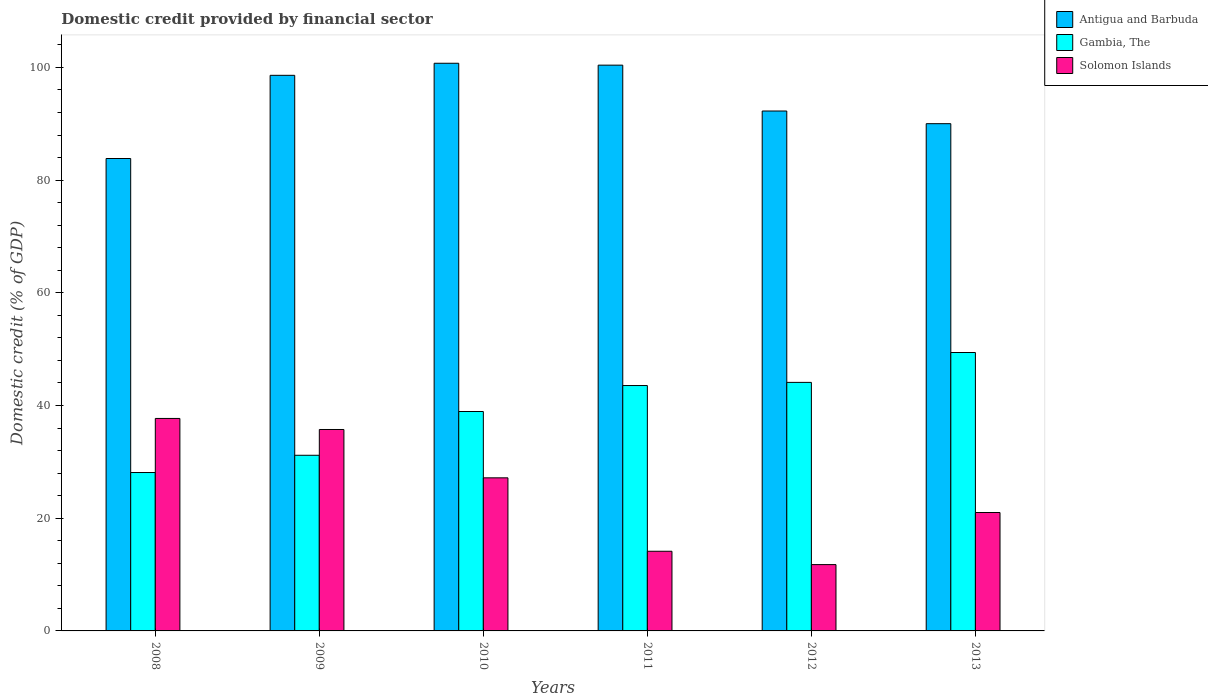How many different coloured bars are there?
Provide a succinct answer. 3. Are the number of bars per tick equal to the number of legend labels?
Keep it short and to the point. Yes. Are the number of bars on each tick of the X-axis equal?
Your answer should be compact. Yes. How many bars are there on the 6th tick from the left?
Make the answer very short. 3. How many bars are there on the 5th tick from the right?
Your response must be concise. 3. In how many cases, is the number of bars for a given year not equal to the number of legend labels?
Make the answer very short. 0. What is the domestic credit in Solomon Islands in 2010?
Your answer should be compact. 27.17. Across all years, what is the maximum domestic credit in Antigua and Barbuda?
Give a very brief answer. 100.74. Across all years, what is the minimum domestic credit in Gambia, The?
Make the answer very short. 28.11. In which year was the domestic credit in Gambia, The minimum?
Give a very brief answer. 2008. What is the total domestic credit in Antigua and Barbuda in the graph?
Your answer should be compact. 565.87. What is the difference between the domestic credit in Solomon Islands in 2010 and that in 2011?
Offer a very short reply. 13.03. What is the difference between the domestic credit in Solomon Islands in 2008 and the domestic credit in Antigua and Barbuda in 2013?
Offer a very short reply. -52.31. What is the average domestic credit in Solomon Islands per year?
Ensure brevity in your answer.  24.59. In the year 2010, what is the difference between the domestic credit in Gambia, The and domestic credit in Solomon Islands?
Make the answer very short. 11.77. In how many years, is the domestic credit in Gambia, The greater than 36 %?
Give a very brief answer. 4. What is the ratio of the domestic credit in Gambia, The in 2008 to that in 2009?
Give a very brief answer. 0.9. Is the difference between the domestic credit in Gambia, The in 2009 and 2013 greater than the difference between the domestic credit in Solomon Islands in 2009 and 2013?
Give a very brief answer. No. What is the difference between the highest and the second highest domestic credit in Gambia, The?
Keep it short and to the point. 5.3. What is the difference between the highest and the lowest domestic credit in Gambia, The?
Offer a terse response. 21.3. In how many years, is the domestic credit in Gambia, The greater than the average domestic credit in Gambia, The taken over all years?
Your answer should be very brief. 3. What does the 3rd bar from the left in 2010 represents?
Provide a short and direct response. Solomon Islands. What does the 1st bar from the right in 2012 represents?
Your answer should be very brief. Solomon Islands. Is it the case that in every year, the sum of the domestic credit in Solomon Islands and domestic credit in Antigua and Barbuda is greater than the domestic credit in Gambia, The?
Provide a succinct answer. Yes. Are all the bars in the graph horizontal?
Offer a very short reply. No. What is the difference between two consecutive major ticks on the Y-axis?
Provide a succinct answer. 20. Are the values on the major ticks of Y-axis written in scientific E-notation?
Provide a short and direct response. No. Does the graph contain grids?
Provide a short and direct response. No. Where does the legend appear in the graph?
Offer a terse response. Top right. What is the title of the graph?
Your answer should be very brief. Domestic credit provided by financial sector. Does "Rwanda" appear as one of the legend labels in the graph?
Give a very brief answer. No. What is the label or title of the X-axis?
Ensure brevity in your answer.  Years. What is the label or title of the Y-axis?
Keep it short and to the point. Domestic credit (% of GDP). What is the Domestic credit (% of GDP) of Antigua and Barbuda in 2008?
Ensure brevity in your answer.  83.84. What is the Domestic credit (% of GDP) of Gambia, The in 2008?
Your answer should be very brief. 28.11. What is the Domestic credit (% of GDP) of Solomon Islands in 2008?
Your response must be concise. 37.71. What is the Domestic credit (% of GDP) of Antigua and Barbuda in 2009?
Ensure brevity in your answer.  98.6. What is the Domestic credit (% of GDP) in Gambia, The in 2009?
Offer a terse response. 31.17. What is the Domestic credit (% of GDP) of Solomon Islands in 2009?
Provide a short and direct response. 35.75. What is the Domestic credit (% of GDP) in Antigua and Barbuda in 2010?
Give a very brief answer. 100.74. What is the Domestic credit (% of GDP) of Gambia, The in 2010?
Provide a short and direct response. 38.94. What is the Domestic credit (% of GDP) in Solomon Islands in 2010?
Provide a short and direct response. 27.17. What is the Domestic credit (% of GDP) in Antigua and Barbuda in 2011?
Provide a short and direct response. 100.4. What is the Domestic credit (% of GDP) of Gambia, The in 2011?
Your answer should be compact. 43.55. What is the Domestic credit (% of GDP) in Solomon Islands in 2011?
Provide a short and direct response. 14.14. What is the Domestic credit (% of GDP) of Antigua and Barbuda in 2012?
Your answer should be very brief. 92.27. What is the Domestic credit (% of GDP) of Gambia, The in 2012?
Give a very brief answer. 44.11. What is the Domestic credit (% of GDP) in Solomon Islands in 2012?
Ensure brevity in your answer.  11.77. What is the Domestic credit (% of GDP) of Antigua and Barbuda in 2013?
Keep it short and to the point. 90.02. What is the Domestic credit (% of GDP) in Gambia, The in 2013?
Ensure brevity in your answer.  49.41. What is the Domestic credit (% of GDP) of Solomon Islands in 2013?
Your response must be concise. 21.01. Across all years, what is the maximum Domestic credit (% of GDP) of Antigua and Barbuda?
Offer a terse response. 100.74. Across all years, what is the maximum Domestic credit (% of GDP) in Gambia, The?
Give a very brief answer. 49.41. Across all years, what is the maximum Domestic credit (% of GDP) in Solomon Islands?
Your answer should be very brief. 37.71. Across all years, what is the minimum Domestic credit (% of GDP) in Antigua and Barbuda?
Your response must be concise. 83.84. Across all years, what is the minimum Domestic credit (% of GDP) in Gambia, The?
Provide a short and direct response. 28.11. Across all years, what is the minimum Domestic credit (% of GDP) in Solomon Islands?
Offer a terse response. 11.77. What is the total Domestic credit (% of GDP) in Antigua and Barbuda in the graph?
Your answer should be compact. 565.87. What is the total Domestic credit (% of GDP) in Gambia, The in the graph?
Provide a short and direct response. 235.28. What is the total Domestic credit (% of GDP) of Solomon Islands in the graph?
Keep it short and to the point. 147.55. What is the difference between the Domestic credit (% of GDP) of Antigua and Barbuda in 2008 and that in 2009?
Give a very brief answer. -14.76. What is the difference between the Domestic credit (% of GDP) in Gambia, The in 2008 and that in 2009?
Provide a succinct answer. -3.06. What is the difference between the Domestic credit (% of GDP) of Solomon Islands in 2008 and that in 2009?
Your answer should be very brief. 1.96. What is the difference between the Domestic credit (% of GDP) in Antigua and Barbuda in 2008 and that in 2010?
Ensure brevity in your answer.  -16.9. What is the difference between the Domestic credit (% of GDP) of Gambia, The in 2008 and that in 2010?
Provide a short and direct response. -10.83. What is the difference between the Domestic credit (% of GDP) in Solomon Islands in 2008 and that in 2010?
Your answer should be compact. 10.54. What is the difference between the Domestic credit (% of GDP) in Antigua and Barbuda in 2008 and that in 2011?
Give a very brief answer. -16.57. What is the difference between the Domestic credit (% of GDP) in Gambia, The in 2008 and that in 2011?
Ensure brevity in your answer.  -15.44. What is the difference between the Domestic credit (% of GDP) in Solomon Islands in 2008 and that in 2011?
Your answer should be very brief. 23.57. What is the difference between the Domestic credit (% of GDP) in Antigua and Barbuda in 2008 and that in 2012?
Your answer should be compact. -8.43. What is the difference between the Domestic credit (% of GDP) in Gambia, The in 2008 and that in 2012?
Keep it short and to the point. -16. What is the difference between the Domestic credit (% of GDP) of Solomon Islands in 2008 and that in 2012?
Provide a succinct answer. 25.94. What is the difference between the Domestic credit (% of GDP) in Antigua and Barbuda in 2008 and that in 2013?
Your answer should be compact. -6.18. What is the difference between the Domestic credit (% of GDP) in Gambia, The in 2008 and that in 2013?
Your answer should be very brief. -21.3. What is the difference between the Domestic credit (% of GDP) in Solomon Islands in 2008 and that in 2013?
Provide a succinct answer. 16.69. What is the difference between the Domestic credit (% of GDP) in Antigua and Barbuda in 2009 and that in 2010?
Offer a very short reply. -2.14. What is the difference between the Domestic credit (% of GDP) in Gambia, The in 2009 and that in 2010?
Offer a terse response. -7.77. What is the difference between the Domestic credit (% of GDP) in Solomon Islands in 2009 and that in 2010?
Ensure brevity in your answer.  8.58. What is the difference between the Domestic credit (% of GDP) of Antigua and Barbuda in 2009 and that in 2011?
Provide a short and direct response. -1.8. What is the difference between the Domestic credit (% of GDP) in Gambia, The in 2009 and that in 2011?
Make the answer very short. -12.37. What is the difference between the Domestic credit (% of GDP) of Solomon Islands in 2009 and that in 2011?
Make the answer very short. 21.61. What is the difference between the Domestic credit (% of GDP) in Antigua and Barbuda in 2009 and that in 2012?
Offer a very short reply. 6.33. What is the difference between the Domestic credit (% of GDP) in Gambia, The in 2009 and that in 2012?
Your answer should be compact. -12.94. What is the difference between the Domestic credit (% of GDP) in Solomon Islands in 2009 and that in 2012?
Provide a short and direct response. 23.98. What is the difference between the Domestic credit (% of GDP) of Antigua and Barbuda in 2009 and that in 2013?
Provide a short and direct response. 8.58. What is the difference between the Domestic credit (% of GDP) of Gambia, The in 2009 and that in 2013?
Give a very brief answer. -18.24. What is the difference between the Domestic credit (% of GDP) in Solomon Islands in 2009 and that in 2013?
Your answer should be compact. 14.73. What is the difference between the Domestic credit (% of GDP) of Antigua and Barbuda in 2010 and that in 2011?
Offer a terse response. 0.34. What is the difference between the Domestic credit (% of GDP) of Gambia, The in 2010 and that in 2011?
Give a very brief answer. -4.61. What is the difference between the Domestic credit (% of GDP) of Solomon Islands in 2010 and that in 2011?
Ensure brevity in your answer.  13.03. What is the difference between the Domestic credit (% of GDP) of Antigua and Barbuda in 2010 and that in 2012?
Give a very brief answer. 8.47. What is the difference between the Domestic credit (% of GDP) in Gambia, The in 2010 and that in 2012?
Offer a terse response. -5.17. What is the difference between the Domestic credit (% of GDP) of Solomon Islands in 2010 and that in 2012?
Your response must be concise. 15.4. What is the difference between the Domestic credit (% of GDP) of Antigua and Barbuda in 2010 and that in 2013?
Ensure brevity in your answer.  10.72. What is the difference between the Domestic credit (% of GDP) of Gambia, The in 2010 and that in 2013?
Your response must be concise. -10.47. What is the difference between the Domestic credit (% of GDP) in Solomon Islands in 2010 and that in 2013?
Your answer should be very brief. 6.15. What is the difference between the Domestic credit (% of GDP) in Antigua and Barbuda in 2011 and that in 2012?
Give a very brief answer. 8.14. What is the difference between the Domestic credit (% of GDP) in Gambia, The in 2011 and that in 2012?
Offer a terse response. -0.56. What is the difference between the Domestic credit (% of GDP) of Solomon Islands in 2011 and that in 2012?
Make the answer very short. 2.37. What is the difference between the Domestic credit (% of GDP) in Antigua and Barbuda in 2011 and that in 2013?
Ensure brevity in your answer.  10.39. What is the difference between the Domestic credit (% of GDP) of Gambia, The in 2011 and that in 2013?
Your answer should be very brief. -5.86. What is the difference between the Domestic credit (% of GDP) of Solomon Islands in 2011 and that in 2013?
Provide a succinct answer. -6.88. What is the difference between the Domestic credit (% of GDP) in Antigua and Barbuda in 2012 and that in 2013?
Your response must be concise. 2.25. What is the difference between the Domestic credit (% of GDP) in Gambia, The in 2012 and that in 2013?
Ensure brevity in your answer.  -5.3. What is the difference between the Domestic credit (% of GDP) of Solomon Islands in 2012 and that in 2013?
Your answer should be very brief. -9.24. What is the difference between the Domestic credit (% of GDP) of Antigua and Barbuda in 2008 and the Domestic credit (% of GDP) of Gambia, The in 2009?
Provide a short and direct response. 52.66. What is the difference between the Domestic credit (% of GDP) in Antigua and Barbuda in 2008 and the Domestic credit (% of GDP) in Solomon Islands in 2009?
Keep it short and to the point. 48.09. What is the difference between the Domestic credit (% of GDP) of Gambia, The in 2008 and the Domestic credit (% of GDP) of Solomon Islands in 2009?
Provide a succinct answer. -7.64. What is the difference between the Domestic credit (% of GDP) in Antigua and Barbuda in 2008 and the Domestic credit (% of GDP) in Gambia, The in 2010?
Your answer should be very brief. 44.9. What is the difference between the Domestic credit (% of GDP) in Antigua and Barbuda in 2008 and the Domestic credit (% of GDP) in Solomon Islands in 2010?
Make the answer very short. 56.67. What is the difference between the Domestic credit (% of GDP) of Gambia, The in 2008 and the Domestic credit (% of GDP) of Solomon Islands in 2010?
Your response must be concise. 0.94. What is the difference between the Domestic credit (% of GDP) of Antigua and Barbuda in 2008 and the Domestic credit (% of GDP) of Gambia, The in 2011?
Your answer should be very brief. 40.29. What is the difference between the Domestic credit (% of GDP) in Antigua and Barbuda in 2008 and the Domestic credit (% of GDP) in Solomon Islands in 2011?
Offer a terse response. 69.7. What is the difference between the Domestic credit (% of GDP) of Gambia, The in 2008 and the Domestic credit (% of GDP) of Solomon Islands in 2011?
Ensure brevity in your answer.  13.97. What is the difference between the Domestic credit (% of GDP) of Antigua and Barbuda in 2008 and the Domestic credit (% of GDP) of Gambia, The in 2012?
Make the answer very short. 39.73. What is the difference between the Domestic credit (% of GDP) of Antigua and Barbuda in 2008 and the Domestic credit (% of GDP) of Solomon Islands in 2012?
Your response must be concise. 72.07. What is the difference between the Domestic credit (% of GDP) in Gambia, The in 2008 and the Domestic credit (% of GDP) in Solomon Islands in 2012?
Offer a terse response. 16.34. What is the difference between the Domestic credit (% of GDP) of Antigua and Barbuda in 2008 and the Domestic credit (% of GDP) of Gambia, The in 2013?
Ensure brevity in your answer.  34.43. What is the difference between the Domestic credit (% of GDP) in Antigua and Barbuda in 2008 and the Domestic credit (% of GDP) in Solomon Islands in 2013?
Your answer should be compact. 62.82. What is the difference between the Domestic credit (% of GDP) of Gambia, The in 2008 and the Domestic credit (% of GDP) of Solomon Islands in 2013?
Provide a short and direct response. 7.1. What is the difference between the Domestic credit (% of GDP) of Antigua and Barbuda in 2009 and the Domestic credit (% of GDP) of Gambia, The in 2010?
Give a very brief answer. 59.66. What is the difference between the Domestic credit (% of GDP) of Antigua and Barbuda in 2009 and the Domestic credit (% of GDP) of Solomon Islands in 2010?
Ensure brevity in your answer.  71.43. What is the difference between the Domestic credit (% of GDP) of Gambia, The in 2009 and the Domestic credit (% of GDP) of Solomon Islands in 2010?
Your answer should be very brief. 4. What is the difference between the Domestic credit (% of GDP) in Antigua and Barbuda in 2009 and the Domestic credit (% of GDP) in Gambia, The in 2011?
Your answer should be compact. 55.05. What is the difference between the Domestic credit (% of GDP) in Antigua and Barbuda in 2009 and the Domestic credit (% of GDP) in Solomon Islands in 2011?
Provide a short and direct response. 84.46. What is the difference between the Domestic credit (% of GDP) in Gambia, The in 2009 and the Domestic credit (% of GDP) in Solomon Islands in 2011?
Offer a terse response. 17.03. What is the difference between the Domestic credit (% of GDP) of Antigua and Barbuda in 2009 and the Domestic credit (% of GDP) of Gambia, The in 2012?
Keep it short and to the point. 54.49. What is the difference between the Domestic credit (% of GDP) of Antigua and Barbuda in 2009 and the Domestic credit (% of GDP) of Solomon Islands in 2012?
Your answer should be compact. 86.83. What is the difference between the Domestic credit (% of GDP) of Gambia, The in 2009 and the Domestic credit (% of GDP) of Solomon Islands in 2012?
Keep it short and to the point. 19.4. What is the difference between the Domestic credit (% of GDP) in Antigua and Barbuda in 2009 and the Domestic credit (% of GDP) in Gambia, The in 2013?
Your answer should be very brief. 49.19. What is the difference between the Domestic credit (% of GDP) in Antigua and Barbuda in 2009 and the Domestic credit (% of GDP) in Solomon Islands in 2013?
Give a very brief answer. 77.59. What is the difference between the Domestic credit (% of GDP) of Gambia, The in 2009 and the Domestic credit (% of GDP) of Solomon Islands in 2013?
Keep it short and to the point. 10.16. What is the difference between the Domestic credit (% of GDP) in Antigua and Barbuda in 2010 and the Domestic credit (% of GDP) in Gambia, The in 2011?
Offer a terse response. 57.2. What is the difference between the Domestic credit (% of GDP) in Antigua and Barbuda in 2010 and the Domestic credit (% of GDP) in Solomon Islands in 2011?
Your response must be concise. 86.6. What is the difference between the Domestic credit (% of GDP) of Gambia, The in 2010 and the Domestic credit (% of GDP) of Solomon Islands in 2011?
Make the answer very short. 24.8. What is the difference between the Domestic credit (% of GDP) in Antigua and Barbuda in 2010 and the Domestic credit (% of GDP) in Gambia, The in 2012?
Your answer should be very brief. 56.63. What is the difference between the Domestic credit (% of GDP) in Antigua and Barbuda in 2010 and the Domestic credit (% of GDP) in Solomon Islands in 2012?
Make the answer very short. 88.97. What is the difference between the Domestic credit (% of GDP) of Gambia, The in 2010 and the Domestic credit (% of GDP) of Solomon Islands in 2012?
Your answer should be very brief. 27.17. What is the difference between the Domestic credit (% of GDP) of Antigua and Barbuda in 2010 and the Domestic credit (% of GDP) of Gambia, The in 2013?
Your answer should be compact. 51.33. What is the difference between the Domestic credit (% of GDP) of Antigua and Barbuda in 2010 and the Domestic credit (% of GDP) of Solomon Islands in 2013?
Ensure brevity in your answer.  79.73. What is the difference between the Domestic credit (% of GDP) in Gambia, The in 2010 and the Domestic credit (% of GDP) in Solomon Islands in 2013?
Make the answer very short. 17.93. What is the difference between the Domestic credit (% of GDP) of Antigua and Barbuda in 2011 and the Domestic credit (% of GDP) of Gambia, The in 2012?
Offer a very short reply. 56.3. What is the difference between the Domestic credit (% of GDP) of Antigua and Barbuda in 2011 and the Domestic credit (% of GDP) of Solomon Islands in 2012?
Provide a succinct answer. 88.64. What is the difference between the Domestic credit (% of GDP) in Gambia, The in 2011 and the Domestic credit (% of GDP) in Solomon Islands in 2012?
Give a very brief answer. 31.78. What is the difference between the Domestic credit (% of GDP) of Antigua and Barbuda in 2011 and the Domestic credit (% of GDP) of Gambia, The in 2013?
Provide a succinct answer. 51. What is the difference between the Domestic credit (% of GDP) in Antigua and Barbuda in 2011 and the Domestic credit (% of GDP) in Solomon Islands in 2013?
Give a very brief answer. 79.39. What is the difference between the Domestic credit (% of GDP) in Gambia, The in 2011 and the Domestic credit (% of GDP) in Solomon Islands in 2013?
Offer a very short reply. 22.53. What is the difference between the Domestic credit (% of GDP) of Antigua and Barbuda in 2012 and the Domestic credit (% of GDP) of Gambia, The in 2013?
Your answer should be compact. 42.86. What is the difference between the Domestic credit (% of GDP) in Antigua and Barbuda in 2012 and the Domestic credit (% of GDP) in Solomon Islands in 2013?
Offer a terse response. 71.25. What is the difference between the Domestic credit (% of GDP) of Gambia, The in 2012 and the Domestic credit (% of GDP) of Solomon Islands in 2013?
Offer a terse response. 23.09. What is the average Domestic credit (% of GDP) in Antigua and Barbuda per year?
Offer a terse response. 94.31. What is the average Domestic credit (% of GDP) of Gambia, The per year?
Offer a terse response. 39.21. What is the average Domestic credit (% of GDP) in Solomon Islands per year?
Ensure brevity in your answer.  24.59. In the year 2008, what is the difference between the Domestic credit (% of GDP) in Antigua and Barbuda and Domestic credit (% of GDP) in Gambia, The?
Your answer should be very brief. 55.73. In the year 2008, what is the difference between the Domestic credit (% of GDP) in Antigua and Barbuda and Domestic credit (% of GDP) in Solomon Islands?
Offer a very short reply. 46.13. In the year 2008, what is the difference between the Domestic credit (% of GDP) of Gambia, The and Domestic credit (% of GDP) of Solomon Islands?
Keep it short and to the point. -9.6. In the year 2009, what is the difference between the Domestic credit (% of GDP) in Antigua and Barbuda and Domestic credit (% of GDP) in Gambia, The?
Provide a short and direct response. 67.43. In the year 2009, what is the difference between the Domestic credit (% of GDP) in Antigua and Barbuda and Domestic credit (% of GDP) in Solomon Islands?
Your response must be concise. 62.85. In the year 2009, what is the difference between the Domestic credit (% of GDP) in Gambia, The and Domestic credit (% of GDP) in Solomon Islands?
Your answer should be compact. -4.57. In the year 2010, what is the difference between the Domestic credit (% of GDP) of Antigua and Barbuda and Domestic credit (% of GDP) of Gambia, The?
Your answer should be very brief. 61.8. In the year 2010, what is the difference between the Domestic credit (% of GDP) of Antigua and Barbuda and Domestic credit (% of GDP) of Solomon Islands?
Provide a succinct answer. 73.57. In the year 2010, what is the difference between the Domestic credit (% of GDP) in Gambia, The and Domestic credit (% of GDP) in Solomon Islands?
Ensure brevity in your answer.  11.77. In the year 2011, what is the difference between the Domestic credit (% of GDP) of Antigua and Barbuda and Domestic credit (% of GDP) of Gambia, The?
Keep it short and to the point. 56.86. In the year 2011, what is the difference between the Domestic credit (% of GDP) in Antigua and Barbuda and Domestic credit (% of GDP) in Solomon Islands?
Make the answer very short. 86.27. In the year 2011, what is the difference between the Domestic credit (% of GDP) in Gambia, The and Domestic credit (% of GDP) in Solomon Islands?
Offer a very short reply. 29.41. In the year 2012, what is the difference between the Domestic credit (% of GDP) in Antigua and Barbuda and Domestic credit (% of GDP) in Gambia, The?
Keep it short and to the point. 48.16. In the year 2012, what is the difference between the Domestic credit (% of GDP) in Antigua and Barbuda and Domestic credit (% of GDP) in Solomon Islands?
Offer a very short reply. 80.5. In the year 2012, what is the difference between the Domestic credit (% of GDP) of Gambia, The and Domestic credit (% of GDP) of Solomon Islands?
Keep it short and to the point. 32.34. In the year 2013, what is the difference between the Domestic credit (% of GDP) of Antigua and Barbuda and Domestic credit (% of GDP) of Gambia, The?
Keep it short and to the point. 40.61. In the year 2013, what is the difference between the Domestic credit (% of GDP) in Antigua and Barbuda and Domestic credit (% of GDP) in Solomon Islands?
Your answer should be very brief. 69. In the year 2013, what is the difference between the Domestic credit (% of GDP) in Gambia, The and Domestic credit (% of GDP) in Solomon Islands?
Your answer should be compact. 28.4. What is the ratio of the Domestic credit (% of GDP) in Antigua and Barbuda in 2008 to that in 2009?
Make the answer very short. 0.85. What is the ratio of the Domestic credit (% of GDP) of Gambia, The in 2008 to that in 2009?
Keep it short and to the point. 0.9. What is the ratio of the Domestic credit (% of GDP) of Solomon Islands in 2008 to that in 2009?
Give a very brief answer. 1.05. What is the ratio of the Domestic credit (% of GDP) of Antigua and Barbuda in 2008 to that in 2010?
Your answer should be very brief. 0.83. What is the ratio of the Domestic credit (% of GDP) in Gambia, The in 2008 to that in 2010?
Provide a succinct answer. 0.72. What is the ratio of the Domestic credit (% of GDP) in Solomon Islands in 2008 to that in 2010?
Offer a terse response. 1.39. What is the ratio of the Domestic credit (% of GDP) of Antigua and Barbuda in 2008 to that in 2011?
Give a very brief answer. 0.83. What is the ratio of the Domestic credit (% of GDP) of Gambia, The in 2008 to that in 2011?
Give a very brief answer. 0.65. What is the ratio of the Domestic credit (% of GDP) of Solomon Islands in 2008 to that in 2011?
Offer a terse response. 2.67. What is the ratio of the Domestic credit (% of GDP) in Antigua and Barbuda in 2008 to that in 2012?
Offer a terse response. 0.91. What is the ratio of the Domestic credit (% of GDP) in Gambia, The in 2008 to that in 2012?
Your answer should be compact. 0.64. What is the ratio of the Domestic credit (% of GDP) in Solomon Islands in 2008 to that in 2012?
Offer a terse response. 3.2. What is the ratio of the Domestic credit (% of GDP) of Antigua and Barbuda in 2008 to that in 2013?
Provide a succinct answer. 0.93. What is the ratio of the Domestic credit (% of GDP) in Gambia, The in 2008 to that in 2013?
Make the answer very short. 0.57. What is the ratio of the Domestic credit (% of GDP) of Solomon Islands in 2008 to that in 2013?
Provide a short and direct response. 1.79. What is the ratio of the Domestic credit (% of GDP) in Antigua and Barbuda in 2009 to that in 2010?
Your response must be concise. 0.98. What is the ratio of the Domestic credit (% of GDP) in Gambia, The in 2009 to that in 2010?
Give a very brief answer. 0.8. What is the ratio of the Domestic credit (% of GDP) in Solomon Islands in 2009 to that in 2010?
Offer a terse response. 1.32. What is the ratio of the Domestic credit (% of GDP) in Gambia, The in 2009 to that in 2011?
Make the answer very short. 0.72. What is the ratio of the Domestic credit (% of GDP) in Solomon Islands in 2009 to that in 2011?
Offer a terse response. 2.53. What is the ratio of the Domestic credit (% of GDP) in Antigua and Barbuda in 2009 to that in 2012?
Offer a very short reply. 1.07. What is the ratio of the Domestic credit (% of GDP) of Gambia, The in 2009 to that in 2012?
Your answer should be compact. 0.71. What is the ratio of the Domestic credit (% of GDP) of Solomon Islands in 2009 to that in 2012?
Provide a short and direct response. 3.04. What is the ratio of the Domestic credit (% of GDP) of Antigua and Barbuda in 2009 to that in 2013?
Your response must be concise. 1.1. What is the ratio of the Domestic credit (% of GDP) in Gambia, The in 2009 to that in 2013?
Your response must be concise. 0.63. What is the ratio of the Domestic credit (% of GDP) of Solomon Islands in 2009 to that in 2013?
Provide a short and direct response. 1.7. What is the ratio of the Domestic credit (% of GDP) in Gambia, The in 2010 to that in 2011?
Your response must be concise. 0.89. What is the ratio of the Domestic credit (% of GDP) in Solomon Islands in 2010 to that in 2011?
Your response must be concise. 1.92. What is the ratio of the Domestic credit (% of GDP) of Antigua and Barbuda in 2010 to that in 2012?
Your answer should be very brief. 1.09. What is the ratio of the Domestic credit (% of GDP) in Gambia, The in 2010 to that in 2012?
Provide a succinct answer. 0.88. What is the ratio of the Domestic credit (% of GDP) in Solomon Islands in 2010 to that in 2012?
Ensure brevity in your answer.  2.31. What is the ratio of the Domestic credit (% of GDP) of Antigua and Barbuda in 2010 to that in 2013?
Provide a succinct answer. 1.12. What is the ratio of the Domestic credit (% of GDP) in Gambia, The in 2010 to that in 2013?
Keep it short and to the point. 0.79. What is the ratio of the Domestic credit (% of GDP) of Solomon Islands in 2010 to that in 2013?
Give a very brief answer. 1.29. What is the ratio of the Domestic credit (% of GDP) in Antigua and Barbuda in 2011 to that in 2012?
Keep it short and to the point. 1.09. What is the ratio of the Domestic credit (% of GDP) of Gambia, The in 2011 to that in 2012?
Your response must be concise. 0.99. What is the ratio of the Domestic credit (% of GDP) in Solomon Islands in 2011 to that in 2012?
Offer a terse response. 1.2. What is the ratio of the Domestic credit (% of GDP) of Antigua and Barbuda in 2011 to that in 2013?
Make the answer very short. 1.12. What is the ratio of the Domestic credit (% of GDP) in Gambia, The in 2011 to that in 2013?
Offer a very short reply. 0.88. What is the ratio of the Domestic credit (% of GDP) of Solomon Islands in 2011 to that in 2013?
Provide a short and direct response. 0.67. What is the ratio of the Domestic credit (% of GDP) in Antigua and Barbuda in 2012 to that in 2013?
Make the answer very short. 1.02. What is the ratio of the Domestic credit (% of GDP) of Gambia, The in 2012 to that in 2013?
Make the answer very short. 0.89. What is the ratio of the Domestic credit (% of GDP) in Solomon Islands in 2012 to that in 2013?
Your response must be concise. 0.56. What is the difference between the highest and the second highest Domestic credit (% of GDP) of Antigua and Barbuda?
Make the answer very short. 0.34. What is the difference between the highest and the second highest Domestic credit (% of GDP) of Gambia, The?
Your response must be concise. 5.3. What is the difference between the highest and the second highest Domestic credit (% of GDP) in Solomon Islands?
Your answer should be very brief. 1.96. What is the difference between the highest and the lowest Domestic credit (% of GDP) in Antigua and Barbuda?
Offer a terse response. 16.9. What is the difference between the highest and the lowest Domestic credit (% of GDP) in Gambia, The?
Your response must be concise. 21.3. What is the difference between the highest and the lowest Domestic credit (% of GDP) of Solomon Islands?
Your answer should be compact. 25.94. 